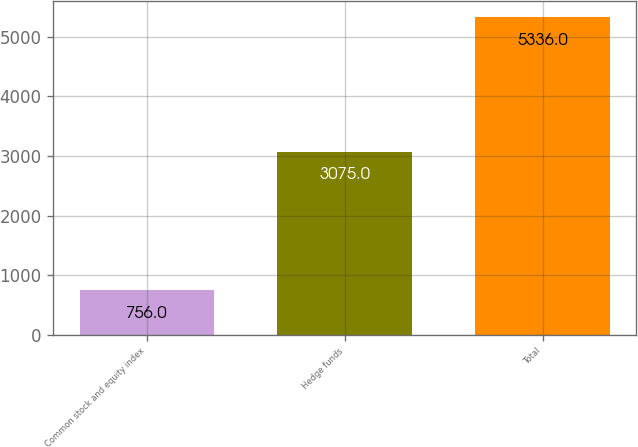Convert chart to OTSL. <chart><loc_0><loc_0><loc_500><loc_500><bar_chart><fcel>Common stock and equity index<fcel>Hedge funds<fcel>Total<nl><fcel>756<fcel>3075<fcel>5336<nl></chart> 